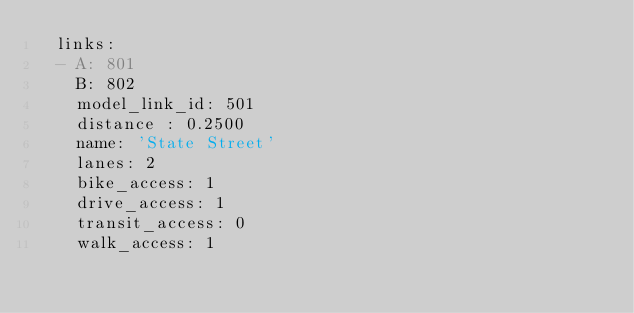<code> <loc_0><loc_0><loc_500><loc_500><_YAML_>  links:
  - A: 801
    B: 802
    model_link_id: 501
    distance : 0.2500
    name: 'State Street'
    lanes: 2
    bike_access: 1
    drive_access: 1
    transit_access: 0
    walk_access: 1
</code> 